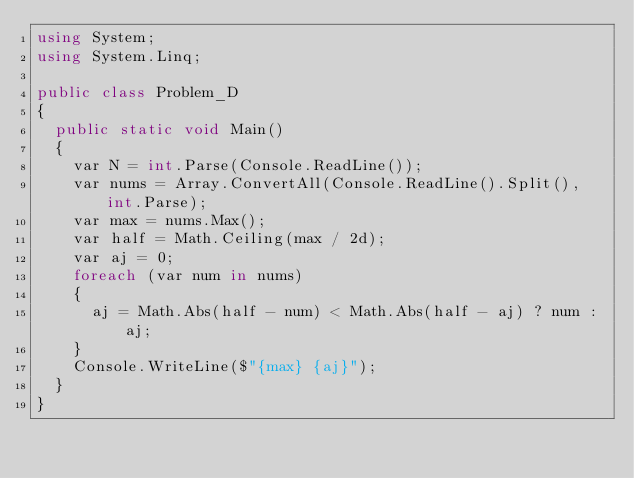Convert code to text. <code><loc_0><loc_0><loc_500><loc_500><_C#_>using System;
using System.Linq;

public class Problem_D
{
  public static void Main()
  {
    var N = int.Parse(Console.ReadLine());
    var nums = Array.ConvertAll(Console.ReadLine().Split(), int.Parse);
    var max = nums.Max();
    var half = Math.Ceiling(max / 2d);
    var aj = 0;
    foreach (var num in nums)
    {
      aj = Math.Abs(half - num) < Math.Abs(half - aj) ? num : aj;
    }
    Console.WriteLine($"{max} {aj}");
  }
}
</code> 